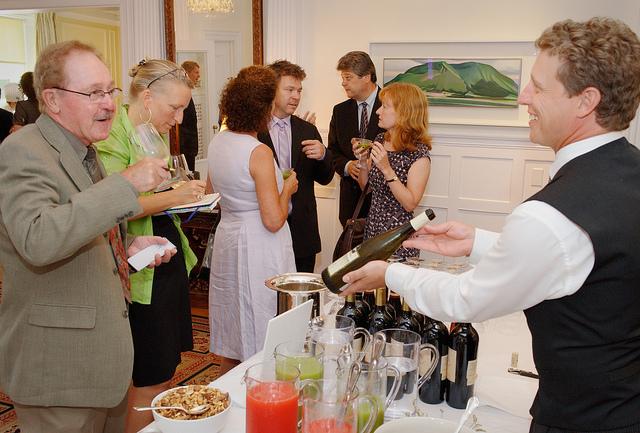Is the juice in the pitcher that is in the foreground tomato juice?
Be succinct. Yes. What have these people just done?
Be succinct. Eaten. Is this a couple?
Keep it brief. No. How many people are serving?
Be succinct. 1. What color are the ties?
Be succinct. Multi. Who is pouring the wine?
Concise answer only. Bartender. Are they all holding liquor bottles?
Write a very short answer. No. Are they having breakfast?
Concise answer only. No. What does the man have on his plate?
Concise answer only. Food. Could this event be in a home?
Keep it brief. Yes. 